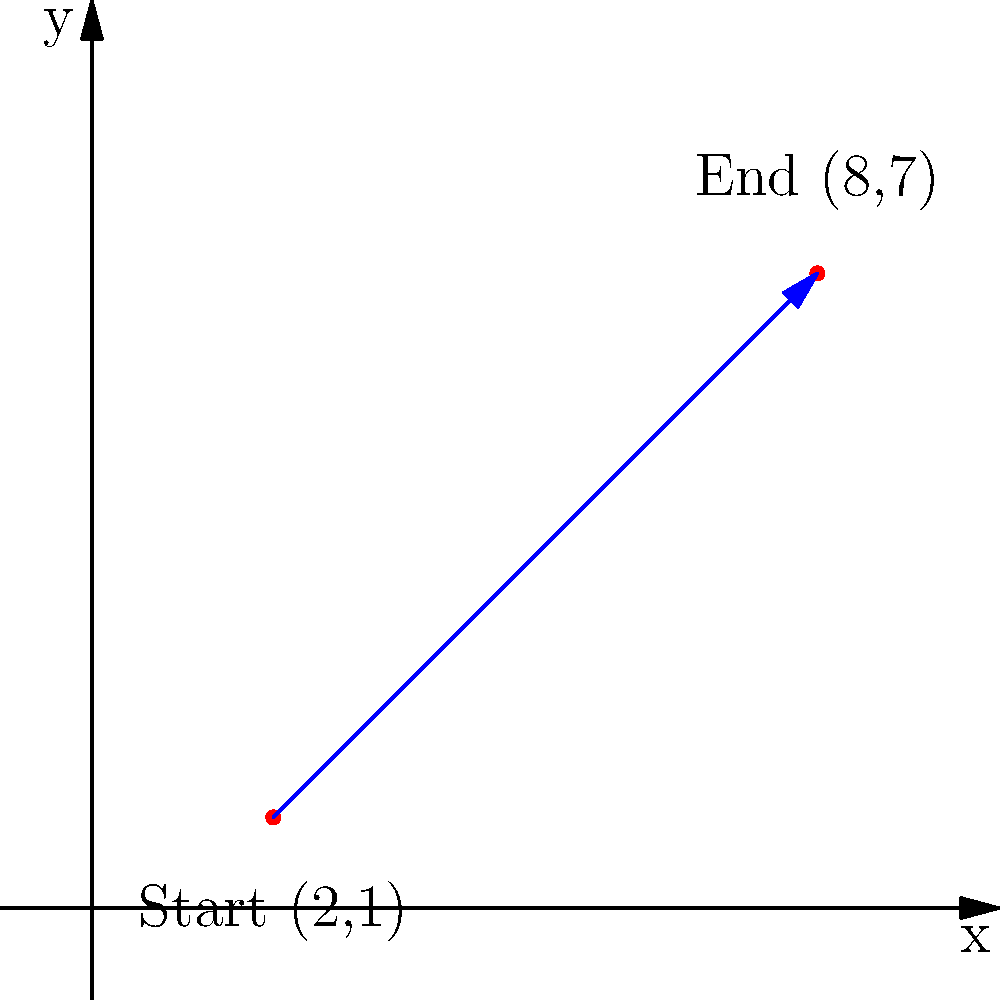During a crucial football match, Michael Gufler made a spectacular run from position (2,1) to (8,7) on the field, represented by a coordinate plane. Find the equation of the line representing Gufler's path in slope-intercept form $(y = mx + b)$. To find the equation of the line representing Michael Gufler's path, we'll follow these steps:

1. Calculate the slope (m) using the two given points:
   $m = \frac{y_2 - y_1}{x_2 - x_1} = \frac{7 - 1}{8 - 2} = \frac{6}{6} = 1$

2. Use the point-slope form of a line: $y - y_1 = m(x - x_1)$
   Let's use the starting point (2,1):
   $y - 1 = 1(x - 2)$

3. Expand the equation:
   $y - 1 = x - 2$

4. Solve for y to get the slope-intercept form:
   $y = x - 2 + 1$
   $y = x - 1$

Therefore, the equation of the line representing Gufler's path is $y = x - 1$.
Answer: $y = x - 1$ 